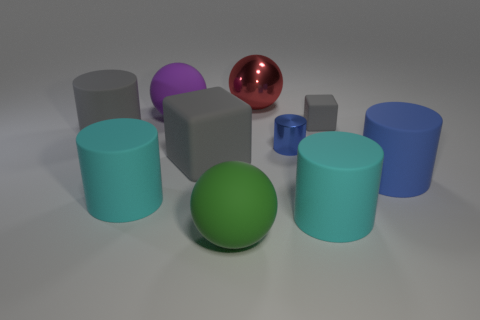How many gray blocks must be subtracted to get 1 gray blocks? 1 Subtract all gray cylinders. How many cylinders are left? 4 Subtract 2 cylinders. How many cylinders are left? 3 Subtract all big blue matte cylinders. How many cylinders are left? 4 Subtract all brown cylinders. Subtract all red blocks. How many cylinders are left? 5 Subtract all cubes. How many objects are left? 8 Add 1 rubber cubes. How many rubber cubes are left? 3 Add 4 gray cylinders. How many gray cylinders exist? 5 Subtract 0 gray balls. How many objects are left? 10 Subtract all shiny balls. Subtract all red objects. How many objects are left? 8 